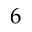<formula> <loc_0><loc_0><loc_500><loc_500>6</formula> 